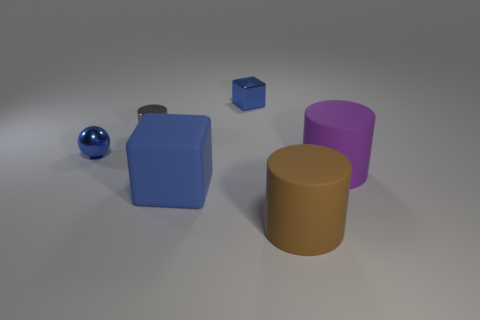What size is the cube that is in front of the cylinder right of the cylinder in front of the purple rubber thing?
Provide a short and direct response. Large. How many big blue cubes have the same material as the small gray object?
Offer a very short reply. 0. Are there fewer yellow spheres than brown rubber cylinders?
Keep it short and to the point. Yes. What size is the brown thing that is the same shape as the big purple matte thing?
Ensure brevity in your answer.  Large. Is the big object that is behind the matte block made of the same material as the tiny blue sphere?
Offer a very short reply. No. Does the big brown rubber object have the same shape as the big purple rubber object?
Your answer should be compact. Yes. What number of objects are either metallic objects that are behind the blue ball or blue metal balls?
Give a very brief answer. 3. The block that is made of the same material as the small gray thing is what size?
Make the answer very short. Small. What number of small metallic balls are the same color as the large block?
Provide a succinct answer. 1. How many tiny objects are either purple matte objects or metal things?
Give a very brief answer. 3. 